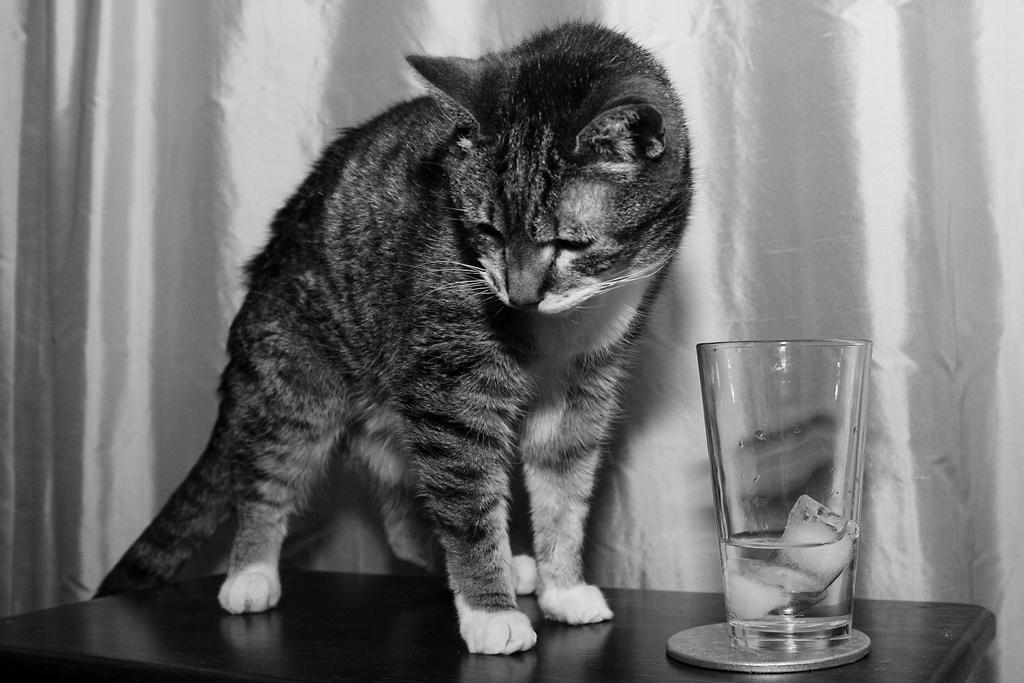What type of furniture is in the image? There is a table in the image. What animal is on the table? A cat is present on the table. What object is also on the table? There is a glass on the table. What can be seen in the background of the image? There is a cloth visible in the background of the image. How does the cat embark on a voyage in the image? The cat does not embark on a voyage in the image; it is simply sitting on the table. 